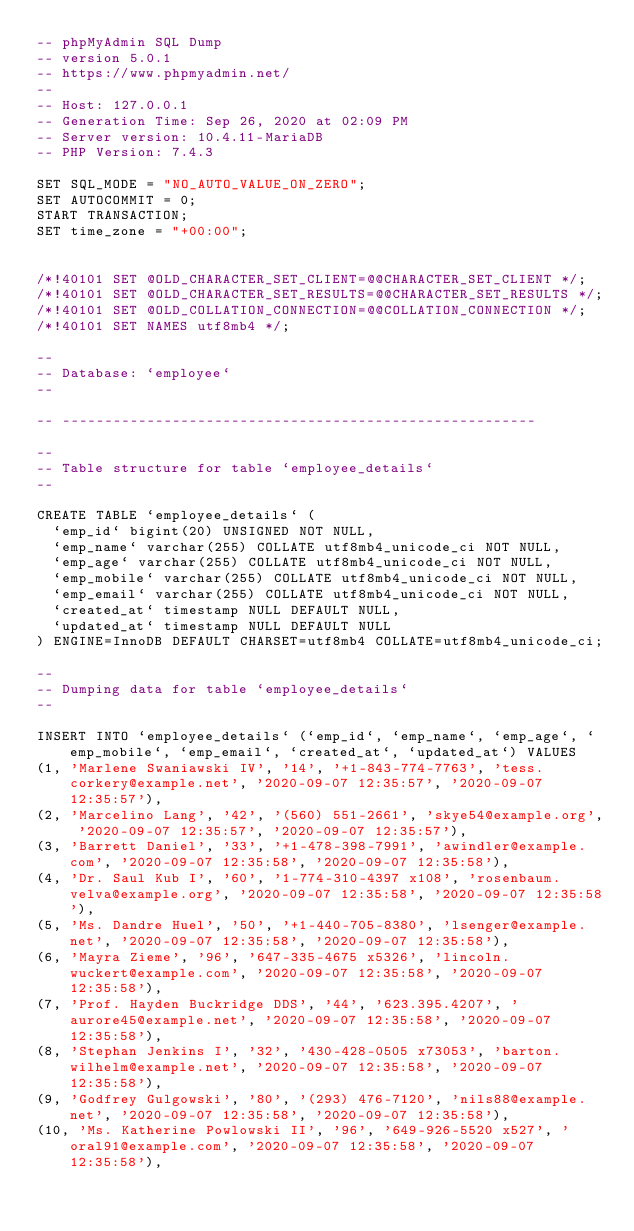<code> <loc_0><loc_0><loc_500><loc_500><_SQL_>-- phpMyAdmin SQL Dump
-- version 5.0.1
-- https://www.phpmyadmin.net/
--
-- Host: 127.0.0.1
-- Generation Time: Sep 26, 2020 at 02:09 PM
-- Server version: 10.4.11-MariaDB
-- PHP Version: 7.4.3

SET SQL_MODE = "NO_AUTO_VALUE_ON_ZERO";
SET AUTOCOMMIT = 0;
START TRANSACTION;
SET time_zone = "+00:00";


/*!40101 SET @OLD_CHARACTER_SET_CLIENT=@@CHARACTER_SET_CLIENT */;
/*!40101 SET @OLD_CHARACTER_SET_RESULTS=@@CHARACTER_SET_RESULTS */;
/*!40101 SET @OLD_COLLATION_CONNECTION=@@COLLATION_CONNECTION */;
/*!40101 SET NAMES utf8mb4 */;

--
-- Database: `employee`
--

-- --------------------------------------------------------

--
-- Table structure for table `employee_details`
--

CREATE TABLE `employee_details` (
  `emp_id` bigint(20) UNSIGNED NOT NULL,
  `emp_name` varchar(255) COLLATE utf8mb4_unicode_ci NOT NULL,
  `emp_age` varchar(255) COLLATE utf8mb4_unicode_ci NOT NULL,
  `emp_mobile` varchar(255) COLLATE utf8mb4_unicode_ci NOT NULL,
  `emp_email` varchar(255) COLLATE utf8mb4_unicode_ci NOT NULL,
  `created_at` timestamp NULL DEFAULT NULL,
  `updated_at` timestamp NULL DEFAULT NULL
) ENGINE=InnoDB DEFAULT CHARSET=utf8mb4 COLLATE=utf8mb4_unicode_ci;

--
-- Dumping data for table `employee_details`
--

INSERT INTO `employee_details` (`emp_id`, `emp_name`, `emp_age`, `emp_mobile`, `emp_email`, `created_at`, `updated_at`) VALUES
(1, 'Marlene Swaniawski IV', '14', '+1-843-774-7763', 'tess.corkery@example.net', '2020-09-07 12:35:57', '2020-09-07 12:35:57'),
(2, 'Marcelino Lang', '42', '(560) 551-2661', 'skye54@example.org', '2020-09-07 12:35:57', '2020-09-07 12:35:57'),
(3, 'Barrett Daniel', '33', '+1-478-398-7991', 'awindler@example.com', '2020-09-07 12:35:58', '2020-09-07 12:35:58'),
(4, 'Dr. Saul Kub I', '60', '1-774-310-4397 x108', 'rosenbaum.velva@example.org', '2020-09-07 12:35:58', '2020-09-07 12:35:58'),
(5, 'Ms. Dandre Huel', '50', '+1-440-705-8380', 'lsenger@example.net', '2020-09-07 12:35:58', '2020-09-07 12:35:58'),
(6, 'Mayra Zieme', '96', '647-335-4675 x5326', 'lincoln.wuckert@example.com', '2020-09-07 12:35:58', '2020-09-07 12:35:58'),
(7, 'Prof. Hayden Buckridge DDS', '44', '623.395.4207', 'aurore45@example.net', '2020-09-07 12:35:58', '2020-09-07 12:35:58'),
(8, 'Stephan Jenkins I', '32', '430-428-0505 x73053', 'barton.wilhelm@example.net', '2020-09-07 12:35:58', '2020-09-07 12:35:58'),
(9, 'Godfrey Gulgowski', '80', '(293) 476-7120', 'nils88@example.net', '2020-09-07 12:35:58', '2020-09-07 12:35:58'),
(10, 'Ms. Katherine Powlowski II', '96', '649-926-5520 x527', 'oral91@example.com', '2020-09-07 12:35:58', '2020-09-07 12:35:58'),</code> 